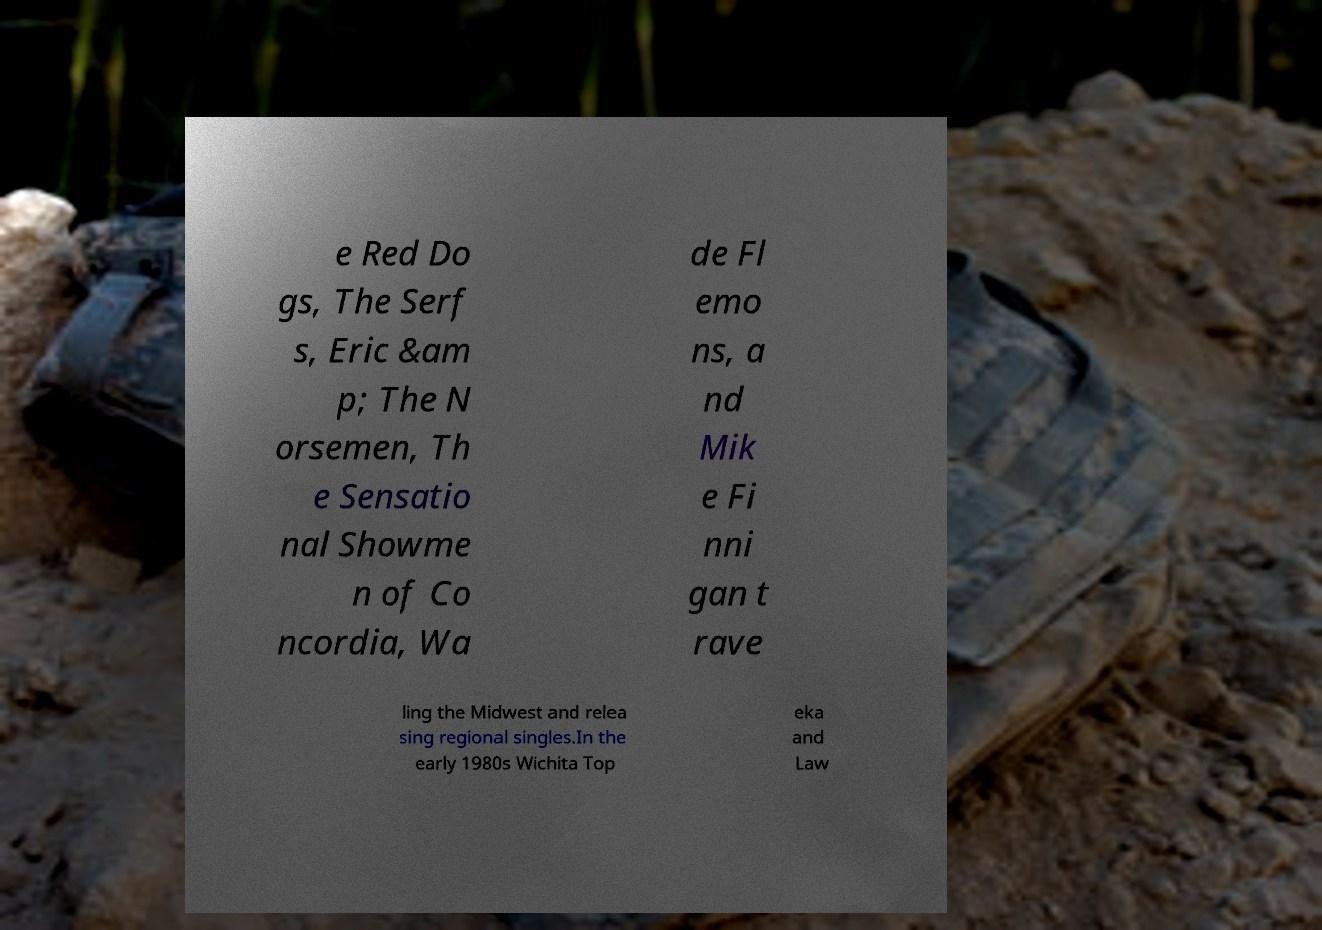Please identify and transcribe the text found in this image. e Red Do gs, The Serf s, Eric &am p; The N orsemen, Th e Sensatio nal Showme n of Co ncordia, Wa de Fl emo ns, a nd Mik e Fi nni gan t rave ling the Midwest and relea sing regional singles.In the early 1980s Wichita Top eka and Law 